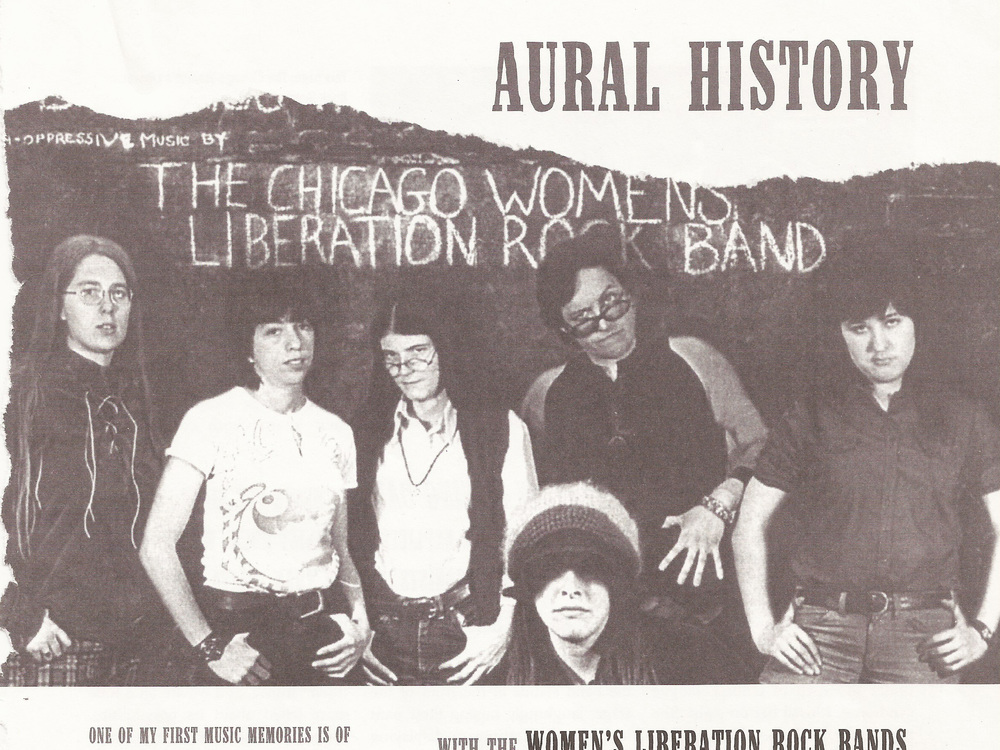Can you describe the style and atmosphere conveyed by the background and setting of the band in this image? The background, featuring a roughly textured chalkboard-like surface with the words 'The Chicago Women’s Liberation Rock Band' scribbled across, delivers a raw, grassroots feel. This kind of ambiance aligns with the DIY aesthetics often embraced by revolutionary movements in the 1970s. The informal, direct style suggests a setting that is both intimate and politically charged, likely aiming to convey a sense of community and common cause in their musical expressions. 